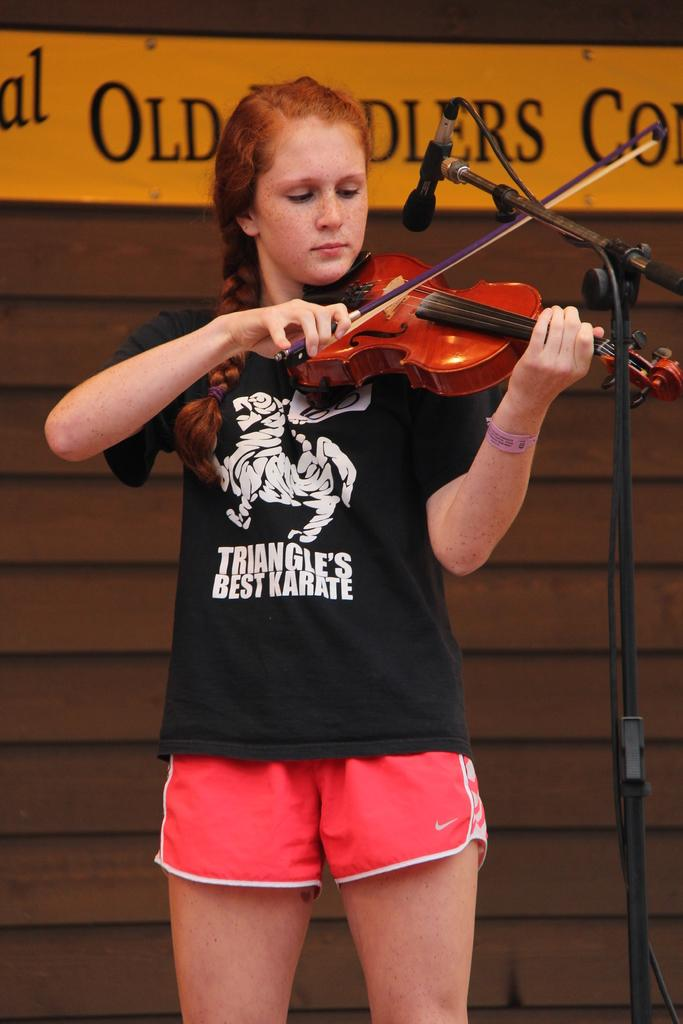<image>
Give a short and clear explanation of the subsequent image. Girl wearing a shirt which says "Triangle's best karate" playing the violin. 